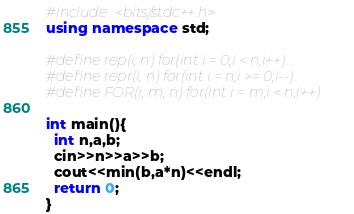<code> <loc_0><loc_0><loc_500><loc_500><_C++_>#include <bits/stdc++.h>
using namespace std;

#define rep(i, n) for(int i = 0;i < n;i++)
#define repr(i, n) for(int i = n;i >= 0;i--)
#define FOR(i, m, n) for(int i = m;i < n;i++)

int main(){
  int n,a,b;
  cin>>n>>a>>b;
  cout<<min(b,a*n)<<endl;
  return 0;
}</code> 